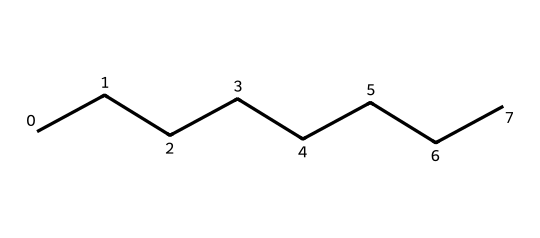What is the molecular formula of octane? The SMILES representation shows a straight chain of eight carbon atoms. Each carbon is bonded to enough hydrogen atoms to satisfy its tetravalency. Therefore, the molecular formula can be derived as C8H18.
Answer: C8H18 How many carbon atoms are in octane? The SMILES representation contains a chain of eight 'C' symbols, indicating the presence of eight carbon atoms in the structure.
Answer: 8 What type of hydrocarbon is octane? Given that octane has only single carbon-carbon bonds and is fully saturated with hydrogen, it is classified as an alkane, a type of hydrocarbon characterized by single bonds.
Answer: alkane How many hydrogen atoms does octane have? In the molecular formula C8H18 derived from the SMILES representation, the hydrogen component is identified as 18, confirming the number of hydrogen atoms.
Answer: 18 Is octane a straight-chain or branched hydrocarbon? The SMILES representation shows a continuous linear sequence of carbon atoms (no branching), indicating that octane is a straight-chain hydrocarbon.
Answer: straight-chain What characteristic property does octane provide to gasoline? Octane is known for its high energy content and helps prevent engine knocking, making it an important fuel component in gasoline.
Answer: prevents knocking 